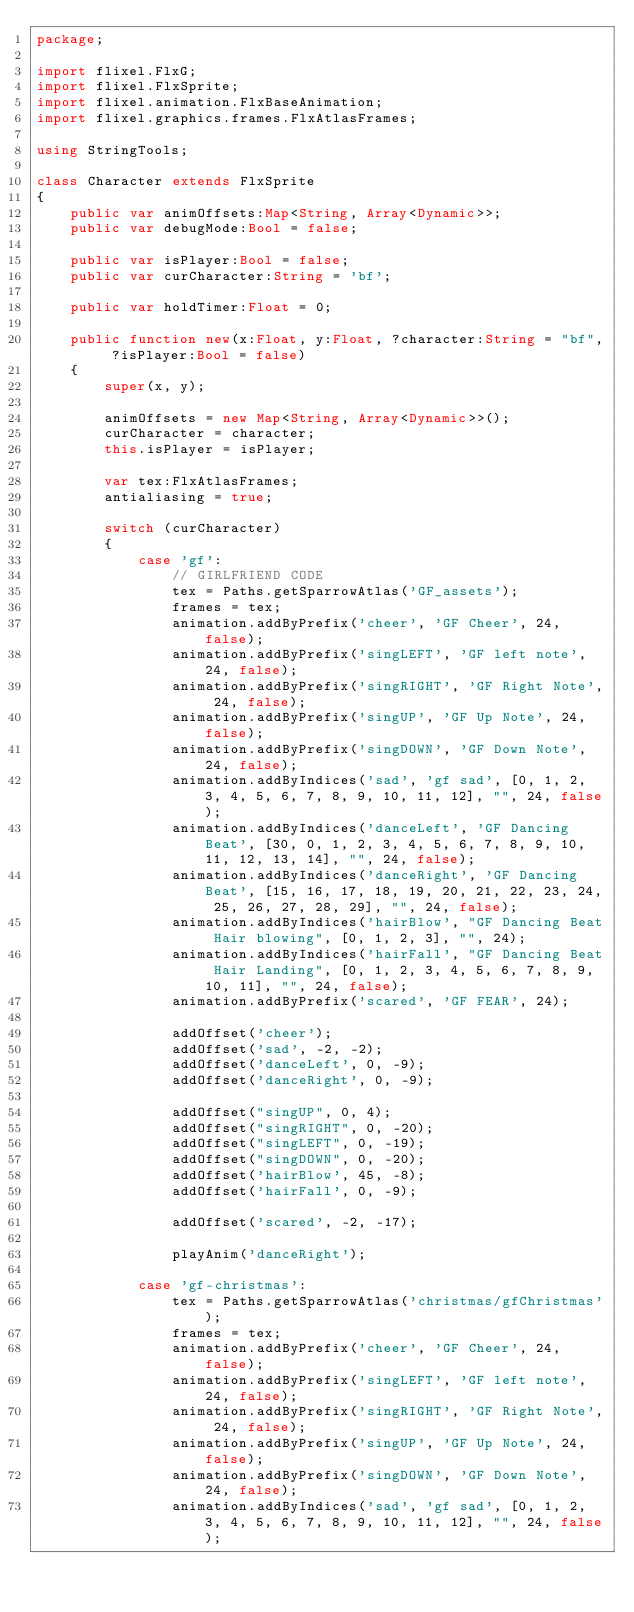Convert code to text. <code><loc_0><loc_0><loc_500><loc_500><_Haxe_>package;

import flixel.FlxG;
import flixel.FlxSprite;
import flixel.animation.FlxBaseAnimation;
import flixel.graphics.frames.FlxAtlasFrames;

using StringTools;

class Character extends FlxSprite
{
	public var animOffsets:Map<String, Array<Dynamic>>;
	public var debugMode:Bool = false;

	public var isPlayer:Bool = false;
	public var curCharacter:String = 'bf';

	public var holdTimer:Float = 0;

	public function new(x:Float, y:Float, ?character:String = "bf", ?isPlayer:Bool = false)
	{
		super(x, y);

		animOffsets = new Map<String, Array<Dynamic>>();
		curCharacter = character;
		this.isPlayer = isPlayer;

		var tex:FlxAtlasFrames;
		antialiasing = true;

		switch (curCharacter)
		{
			case 'gf':
				// GIRLFRIEND CODE
				tex = Paths.getSparrowAtlas('GF_assets');
				frames = tex;
				animation.addByPrefix('cheer', 'GF Cheer', 24, false);
				animation.addByPrefix('singLEFT', 'GF left note', 24, false);
				animation.addByPrefix('singRIGHT', 'GF Right Note', 24, false);
				animation.addByPrefix('singUP', 'GF Up Note', 24, false);
				animation.addByPrefix('singDOWN', 'GF Down Note', 24, false);
				animation.addByIndices('sad', 'gf sad', [0, 1, 2, 3, 4, 5, 6, 7, 8, 9, 10, 11, 12], "", 24, false);
				animation.addByIndices('danceLeft', 'GF Dancing Beat', [30, 0, 1, 2, 3, 4, 5, 6, 7, 8, 9, 10, 11, 12, 13, 14], "", 24, false);
				animation.addByIndices('danceRight', 'GF Dancing Beat', [15, 16, 17, 18, 19, 20, 21, 22, 23, 24, 25, 26, 27, 28, 29], "", 24, false);
				animation.addByIndices('hairBlow', "GF Dancing Beat Hair blowing", [0, 1, 2, 3], "", 24);
				animation.addByIndices('hairFall', "GF Dancing Beat Hair Landing", [0, 1, 2, 3, 4, 5, 6, 7, 8, 9, 10, 11], "", 24, false);
				animation.addByPrefix('scared', 'GF FEAR', 24);

				addOffset('cheer');
				addOffset('sad', -2, -2);
				addOffset('danceLeft', 0, -9);
				addOffset('danceRight', 0, -9);

				addOffset("singUP", 0, 4);
				addOffset("singRIGHT", 0, -20);
				addOffset("singLEFT", 0, -19);
				addOffset("singDOWN", 0, -20);
				addOffset('hairBlow', 45, -8);
				addOffset('hairFall', 0, -9);

				addOffset('scared', -2, -17);

				playAnim('danceRight');

			case 'gf-christmas':
				tex = Paths.getSparrowAtlas('christmas/gfChristmas');
				frames = tex;
				animation.addByPrefix('cheer', 'GF Cheer', 24, false);
				animation.addByPrefix('singLEFT', 'GF left note', 24, false);
				animation.addByPrefix('singRIGHT', 'GF Right Note', 24, false);
				animation.addByPrefix('singUP', 'GF Up Note', 24, false);
				animation.addByPrefix('singDOWN', 'GF Down Note', 24, false);
				animation.addByIndices('sad', 'gf sad', [0, 1, 2, 3, 4, 5, 6, 7, 8, 9, 10, 11, 12], "", 24, false);</code> 